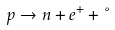Convert formula to latex. <formula><loc_0><loc_0><loc_500><loc_500>p \rightarrow n + e ^ { + } + \nu</formula> 